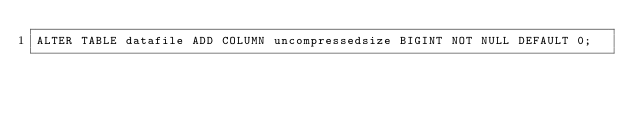Convert code to text. <code><loc_0><loc_0><loc_500><loc_500><_SQL_>ALTER TABLE datafile ADD COLUMN uncompressedsize BIGINT NOT NULL DEFAULT 0;</code> 